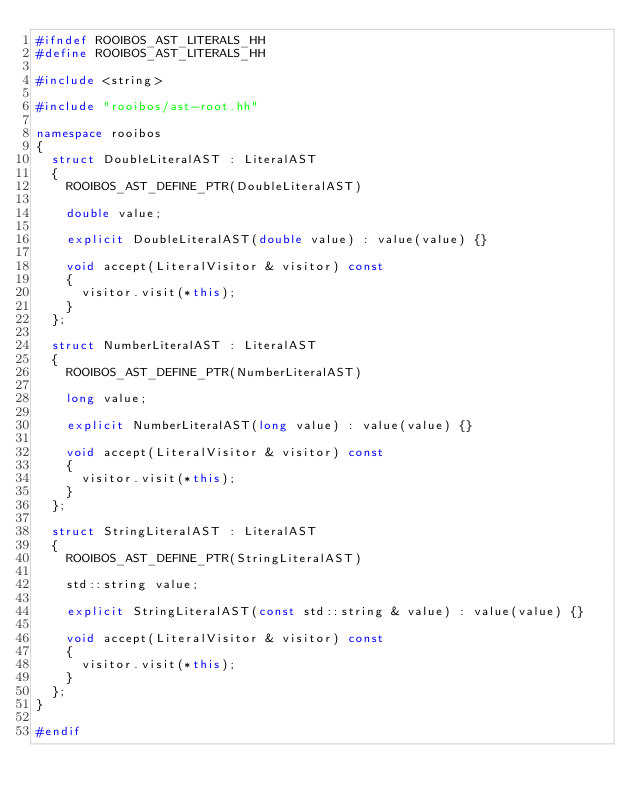<code> <loc_0><loc_0><loc_500><loc_500><_C++_>#ifndef ROOIBOS_AST_LITERALS_HH
#define ROOIBOS_AST_LITERALS_HH

#include <string>

#include "rooibos/ast-root.hh"

namespace rooibos
{
  struct DoubleLiteralAST : LiteralAST
  {
    ROOIBOS_AST_DEFINE_PTR(DoubleLiteralAST)

    double value;

    explicit DoubleLiteralAST(double value) : value(value) {}

    void accept(LiteralVisitor & visitor) const
    {
      visitor.visit(*this);
    }
  };

  struct NumberLiteralAST : LiteralAST
  {
    ROOIBOS_AST_DEFINE_PTR(NumberLiteralAST)

    long value;

    explicit NumberLiteralAST(long value) : value(value) {}

    void accept(LiteralVisitor & visitor) const
    {
      visitor.visit(*this);
    }
  };

  struct StringLiteralAST : LiteralAST
  {
    ROOIBOS_AST_DEFINE_PTR(StringLiteralAST)

    std::string value;

    explicit StringLiteralAST(const std::string & value) : value(value) {}

    void accept(LiteralVisitor & visitor) const
    {
      visitor.visit(*this);
    }
  };
}

#endif
</code> 